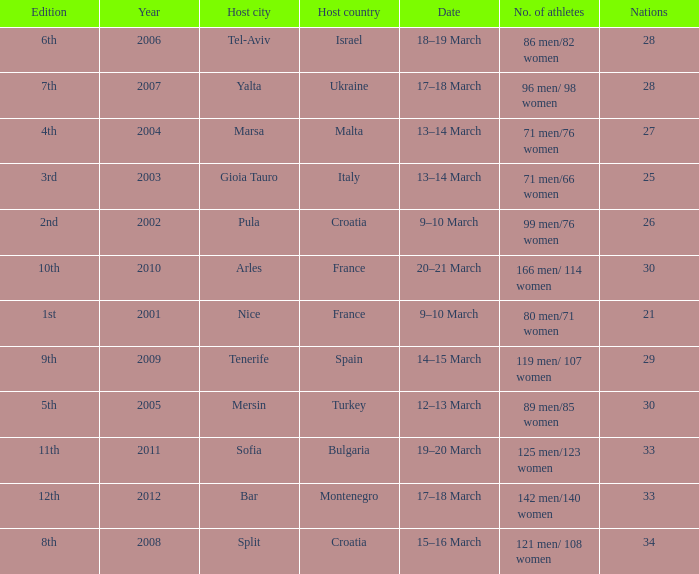What was the number of athletes for the 7th edition? 96 men/ 98 women. 